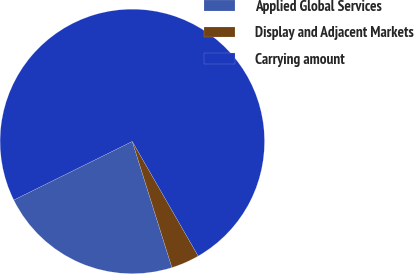<chart> <loc_0><loc_0><loc_500><loc_500><pie_chart><fcel>Applied Global Services<fcel>Display and Adjacent Markets<fcel>Carrying amount<nl><fcel>22.54%<fcel>3.46%<fcel>74.0%<nl></chart> 